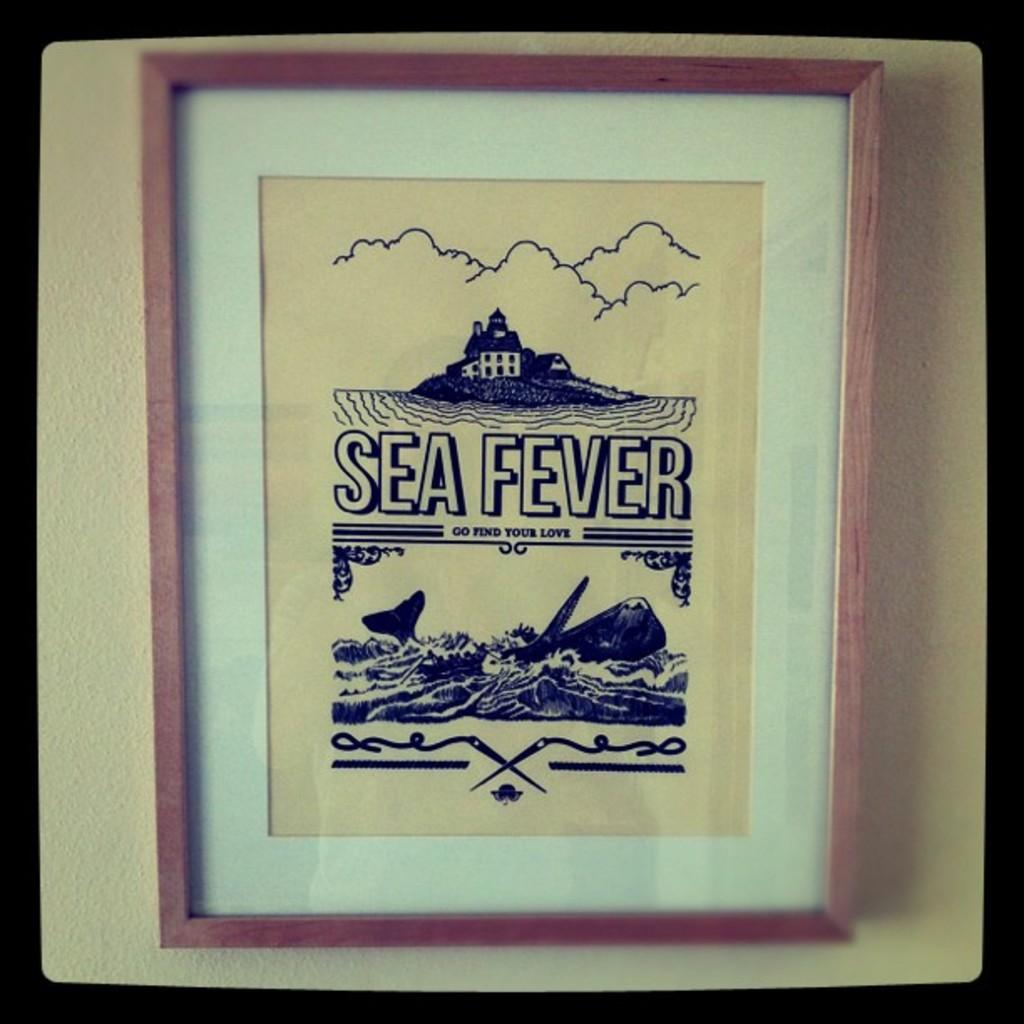<image>
Give a short and clear explanation of the subsequent image. a photo that has the words sea fever on it 